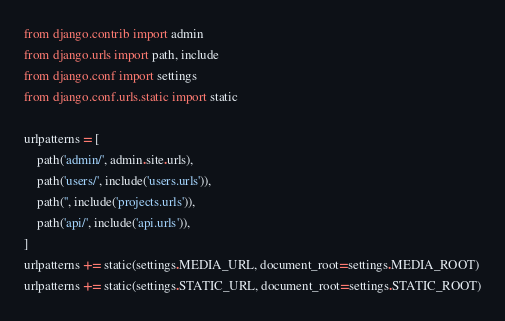Convert code to text. <code><loc_0><loc_0><loc_500><loc_500><_Python_>from django.contrib import admin
from django.urls import path, include
from django.conf import settings
from django.conf.urls.static import static

urlpatterns = [
    path('admin/', admin.site.urls),
    path('users/', include('users.urls')),
    path('', include('projects.urls')),
    path('api/', include('api.urls')),
]
urlpatterns += static(settings.MEDIA_URL, document_root=settings.MEDIA_ROOT)
urlpatterns += static(settings.STATIC_URL, document_root=settings.STATIC_ROOT)
</code> 